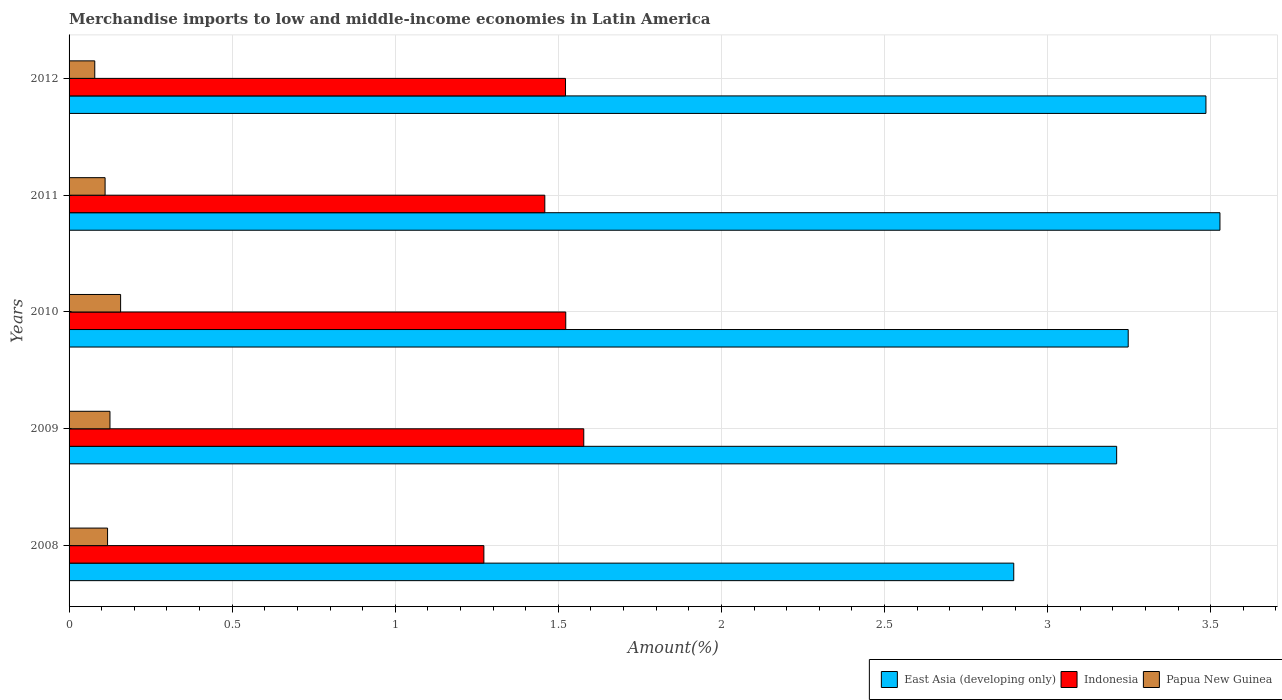How many different coloured bars are there?
Your answer should be compact. 3. How many groups of bars are there?
Give a very brief answer. 5. Are the number of bars on each tick of the Y-axis equal?
Make the answer very short. Yes. What is the label of the 4th group of bars from the top?
Ensure brevity in your answer.  2009. In how many cases, is the number of bars for a given year not equal to the number of legend labels?
Your response must be concise. 0. What is the percentage of amount earned from merchandise imports in East Asia (developing only) in 2008?
Offer a terse response. 2.9. Across all years, what is the maximum percentage of amount earned from merchandise imports in Papua New Guinea?
Offer a very short reply. 0.16. Across all years, what is the minimum percentage of amount earned from merchandise imports in Papua New Guinea?
Make the answer very short. 0.08. In which year was the percentage of amount earned from merchandise imports in Indonesia minimum?
Make the answer very short. 2008. What is the total percentage of amount earned from merchandise imports in Papua New Guinea in the graph?
Provide a succinct answer. 0.59. What is the difference between the percentage of amount earned from merchandise imports in Indonesia in 2009 and that in 2011?
Offer a terse response. 0.12. What is the difference between the percentage of amount earned from merchandise imports in Papua New Guinea in 2009 and the percentage of amount earned from merchandise imports in East Asia (developing only) in 2012?
Offer a very short reply. -3.36. What is the average percentage of amount earned from merchandise imports in Papua New Guinea per year?
Ensure brevity in your answer.  0.12. In the year 2009, what is the difference between the percentage of amount earned from merchandise imports in Indonesia and percentage of amount earned from merchandise imports in East Asia (developing only)?
Your response must be concise. -1.63. In how many years, is the percentage of amount earned from merchandise imports in Papua New Guinea greater than 2.7 %?
Ensure brevity in your answer.  0. What is the ratio of the percentage of amount earned from merchandise imports in East Asia (developing only) in 2010 to that in 2011?
Give a very brief answer. 0.92. What is the difference between the highest and the second highest percentage of amount earned from merchandise imports in Indonesia?
Your answer should be very brief. 0.06. What is the difference between the highest and the lowest percentage of amount earned from merchandise imports in Indonesia?
Make the answer very short. 0.31. In how many years, is the percentage of amount earned from merchandise imports in Papua New Guinea greater than the average percentage of amount earned from merchandise imports in Papua New Guinea taken over all years?
Offer a terse response. 2. What does the 3rd bar from the top in 2012 represents?
Ensure brevity in your answer.  East Asia (developing only). What does the 3rd bar from the bottom in 2012 represents?
Provide a short and direct response. Papua New Guinea. Is it the case that in every year, the sum of the percentage of amount earned from merchandise imports in East Asia (developing only) and percentage of amount earned from merchandise imports in Papua New Guinea is greater than the percentage of amount earned from merchandise imports in Indonesia?
Give a very brief answer. Yes. How many bars are there?
Provide a succinct answer. 15. Are all the bars in the graph horizontal?
Make the answer very short. Yes. How many years are there in the graph?
Provide a succinct answer. 5. What is the difference between two consecutive major ticks on the X-axis?
Make the answer very short. 0.5. Are the values on the major ticks of X-axis written in scientific E-notation?
Keep it short and to the point. No. Where does the legend appear in the graph?
Offer a very short reply. Bottom right. How many legend labels are there?
Ensure brevity in your answer.  3. What is the title of the graph?
Your answer should be very brief. Merchandise imports to low and middle-income economies in Latin America. Does "Portugal" appear as one of the legend labels in the graph?
Your answer should be compact. No. What is the label or title of the X-axis?
Provide a succinct answer. Amount(%). What is the Amount(%) in East Asia (developing only) in 2008?
Offer a very short reply. 2.9. What is the Amount(%) in Indonesia in 2008?
Ensure brevity in your answer.  1.27. What is the Amount(%) of Papua New Guinea in 2008?
Your answer should be compact. 0.12. What is the Amount(%) of East Asia (developing only) in 2009?
Your answer should be compact. 3.21. What is the Amount(%) of Indonesia in 2009?
Ensure brevity in your answer.  1.58. What is the Amount(%) in Papua New Guinea in 2009?
Provide a short and direct response. 0.13. What is the Amount(%) of East Asia (developing only) in 2010?
Make the answer very short. 3.25. What is the Amount(%) of Indonesia in 2010?
Offer a very short reply. 1.52. What is the Amount(%) of Papua New Guinea in 2010?
Make the answer very short. 0.16. What is the Amount(%) of East Asia (developing only) in 2011?
Make the answer very short. 3.53. What is the Amount(%) in Indonesia in 2011?
Provide a short and direct response. 1.46. What is the Amount(%) of Papua New Guinea in 2011?
Ensure brevity in your answer.  0.11. What is the Amount(%) in East Asia (developing only) in 2012?
Give a very brief answer. 3.49. What is the Amount(%) of Indonesia in 2012?
Provide a succinct answer. 1.52. What is the Amount(%) in Papua New Guinea in 2012?
Ensure brevity in your answer.  0.08. Across all years, what is the maximum Amount(%) in East Asia (developing only)?
Offer a terse response. 3.53. Across all years, what is the maximum Amount(%) of Indonesia?
Give a very brief answer. 1.58. Across all years, what is the maximum Amount(%) in Papua New Guinea?
Give a very brief answer. 0.16. Across all years, what is the minimum Amount(%) of East Asia (developing only)?
Keep it short and to the point. 2.9. Across all years, what is the minimum Amount(%) of Indonesia?
Provide a succinct answer. 1.27. Across all years, what is the minimum Amount(%) in Papua New Guinea?
Offer a very short reply. 0.08. What is the total Amount(%) in East Asia (developing only) in the graph?
Provide a succinct answer. 16.37. What is the total Amount(%) in Indonesia in the graph?
Your answer should be compact. 7.35. What is the total Amount(%) in Papua New Guinea in the graph?
Keep it short and to the point. 0.59. What is the difference between the Amount(%) in East Asia (developing only) in 2008 and that in 2009?
Your response must be concise. -0.32. What is the difference between the Amount(%) in Indonesia in 2008 and that in 2009?
Your answer should be very brief. -0.31. What is the difference between the Amount(%) in Papua New Guinea in 2008 and that in 2009?
Ensure brevity in your answer.  -0.01. What is the difference between the Amount(%) of East Asia (developing only) in 2008 and that in 2010?
Offer a terse response. -0.35. What is the difference between the Amount(%) of Indonesia in 2008 and that in 2010?
Give a very brief answer. -0.25. What is the difference between the Amount(%) in Papua New Guinea in 2008 and that in 2010?
Your answer should be compact. -0.04. What is the difference between the Amount(%) in East Asia (developing only) in 2008 and that in 2011?
Offer a terse response. -0.63. What is the difference between the Amount(%) in Indonesia in 2008 and that in 2011?
Your answer should be very brief. -0.19. What is the difference between the Amount(%) of Papua New Guinea in 2008 and that in 2011?
Keep it short and to the point. 0.01. What is the difference between the Amount(%) of East Asia (developing only) in 2008 and that in 2012?
Give a very brief answer. -0.59. What is the difference between the Amount(%) of Indonesia in 2008 and that in 2012?
Give a very brief answer. -0.25. What is the difference between the Amount(%) of Papua New Guinea in 2008 and that in 2012?
Provide a short and direct response. 0.04. What is the difference between the Amount(%) in East Asia (developing only) in 2009 and that in 2010?
Make the answer very short. -0.04. What is the difference between the Amount(%) of Indonesia in 2009 and that in 2010?
Keep it short and to the point. 0.06. What is the difference between the Amount(%) of Papua New Guinea in 2009 and that in 2010?
Your answer should be compact. -0.03. What is the difference between the Amount(%) of East Asia (developing only) in 2009 and that in 2011?
Keep it short and to the point. -0.32. What is the difference between the Amount(%) in Indonesia in 2009 and that in 2011?
Your response must be concise. 0.12. What is the difference between the Amount(%) of Papua New Guinea in 2009 and that in 2011?
Keep it short and to the point. 0.01. What is the difference between the Amount(%) in East Asia (developing only) in 2009 and that in 2012?
Your response must be concise. -0.27. What is the difference between the Amount(%) of Indonesia in 2009 and that in 2012?
Offer a terse response. 0.06. What is the difference between the Amount(%) of Papua New Guinea in 2009 and that in 2012?
Your answer should be very brief. 0.05. What is the difference between the Amount(%) in East Asia (developing only) in 2010 and that in 2011?
Offer a very short reply. -0.28. What is the difference between the Amount(%) of Indonesia in 2010 and that in 2011?
Your answer should be very brief. 0.06. What is the difference between the Amount(%) of Papua New Guinea in 2010 and that in 2011?
Your answer should be compact. 0.05. What is the difference between the Amount(%) of East Asia (developing only) in 2010 and that in 2012?
Offer a very short reply. -0.24. What is the difference between the Amount(%) in Indonesia in 2010 and that in 2012?
Give a very brief answer. 0. What is the difference between the Amount(%) in Papua New Guinea in 2010 and that in 2012?
Give a very brief answer. 0.08. What is the difference between the Amount(%) in East Asia (developing only) in 2011 and that in 2012?
Offer a very short reply. 0.04. What is the difference between the Amount(%) of Indonesia in 2011 and that in 2012?
Offer a very short reply. -0.06. What is the difference between the Amount(%) in Papua New Guinea in 2011 and that in 2012?
Offer a terse response. 0.03. What is the difference between the Amount(%) in East Asia (developing only) in 2008 and the Amount(%) in Indonesia in 2009?
Provide a succinct answer. 1.32. What is the difference between the Amount(%) in East Asia (developing only) in 2008 and the Amount(%) in Papua New Guinea in 2009?
Make the answer very short. 2.77. What is the difference between the Amount(%) of Indonesia in 2008 and the Amount(%) of Papua New Guinea in 2009?
Ensure brevity in your answer.  1.15. What is the difference between the Amount(%) of East Asia (developing only) in 2008 and the Amount(%) of Indonesia in 2010?
Provide a short and direct response. 1.37. What is the difference between the Amount(%) in East Asia (developing only) in 2008 and the Amount(%) in Papua New Guinea in 2010?
Give a very brief answer. 2.74. What is the difference between the Amount(%) in Indonesia in 2008 and the Amount(%) in Papua New Guinea in 2010?
Ensure brevity in your answer.  1.11. What is the difference between the Amount(%) of East Asia (developing only) in 2008 and the Amount(%) of Indonesia in 2011?
Your answer should be compact. 1.44. What is the difference between the Amount(%) in East Asia (developing only) in 2008 and the Amount(%) in Papua New Guinea in 2011?
Your answer should be very brief. 2.79. What is the difference between the Amount(%) of Indonesia in 2008 and the Amount(%) of Papua New Guinea in 2011?
Provide a short and direct response. 1.16. What is the difference between the Amount(%) of East Asia (developing only) in 2008 and the Amount(%) of Indonesia in 2012?
Keep it short and to the point. 1.37. What is the difference between the Amount(%) of East Asia (developing only) in 2008 and the Amount(%) of Papua New Guinea in 2012?
Give a very brief answer. 2.82. What is the difference between the Amount(%) of Indonesia in 2008 and the Amount(%) of Papua New Guinea in 2012?
Give a very brief answer. 1.19. What is the difference between the Amount(%) of East Asia (developing only) in 2009 and the Amount(%) of Indonesia in 2010?
Offer a very short reply. 1.69. What is the difference between the Amount(%) in East Asia (developing only) in 2009 and the Amount(%) in Papua New Guinea in 2010?
Offer a very short reply. 3.05. What is the difference between the Amount(%) in Indonesia in 2009 and the Amount(%) in Papua New Guinea in 2010?
Offer a very short reply. 1.42. What is the difference between the Amount(%) in East Asia (developing only) in 2009 and the Amount(%) in Indonesia in 2011?
Provide a succinct answer. 1.75. What is the difference between the Amount(%) of East Asia (developing only) in 2009 and the Amount(%) of Papua New Guinea in 2011?
Offer a very short reply. 3.1. What is the difference between the Amount(%) of Indonesia in 2009 and the Amount(%) of Papua New Guinea in 2011?
Your response must be concise. 1.47. What is the difference between the Amount(%) in East Asia (developing only) in 2009 and the Amount(%) in Indonesia in 2012?
Make the answer very short. 1.69. What is the difference between the Amount(%) in East Asia (developing only) in 2009 and the Amount(%) in Papua New Guinea in 2012?
Provide a short and direct response. 3.13. What is the difference between the Amount(%) in Indonesia in 2009 and the Amount(%) in Papua New Guinea in 2012?
Provide a succinct answer. 1.5. What is the difference between the Amount(%) of East Asia (developing only) in 2010 and the Amount(%) of Indonesia in 2011?
Make the answer very short. 1.79. What is the difference between the Amount(%) of East Asia (developing only) in 2010 and the Amount(%) of Papua New Guinea in 2011?
Your response must be concise. 3.14. What is the difference between the Amount(%) of Indonesia in 2010 and the Amount(%) of Papua New Guinea in 2011?
Offer a terse response. 1.41. What is the difference between the Amount(%) in East Asia (developing only) in 2010 and the Amount(%) in Indonesia in 2012?
Your response must be concise. 1.73. What is the difference between the Amount(%) in East Asia (developing only) in 2010 and the Amount(%) in Papua New Guinea in 2012?
Offer a terse response. 3.17. What is the difference between the Amount(%) in Indonesia in 2010 and the Amount(%) in Papua New Guinea in 2012?
Offer a terse response. 1.44. What is the difference between the Amount(%) in East Asia (developing only) in 2011 and the Amount(%) in Indonesia in 2012?
Your answer should be very brief. 2.01. What is the difference between the Amount(%) in East Asia (developing only) in 2011 and the Amount(%) in Papua New Guinea in 2012?
Offer a terse response. 3.45. What is the difference between the Amount(%) in Indonesia in 2011 and the Amount(%) in Papua New Guinea in 2012?
Your answer should be compact. 1.38. What is the average Amount(%) in East Asia (developing only) per year?
Give a very brief answer. 3.27. What is the average Amount(%) of Indonesia per year?
Provide a succinct answer. 1.47. What is the average Amount(%) in Papua New Guinea per year?
Give a very brief answer. 0.12. In the year 2008, what is the difference between the Amount(%) of East Asia (developing only) and Amount(%) of Indonesia?
Ensure brevity in your answer.  1.62. In the year 2008, what is the difference between the Amount(%) in East Asia (developing only) and Amount(%) in Papua New Guinea?
Your answer should be very brief. 2.78. In the year 2008, what is the difference between the Amount(%) in Indonesia and Amount(%) in Papua New Guinea?
Your answer should be compact. 1.15. In the year 2009, what is the difference between the Amount(%) of East Asia (developing only) and Amount(%) of Indonesia?
Offer a very short reply. 1.63. In the year 2009, what is the difference between the Amount(%) of East Asia (developing only) and Amount(%) of Papua New Guinea?
Offer a terse response. 3.09. In the year 2009, what is the difference between the Amount(%) of Indonesia and Amount(%) of Papua New Guinea?
Provide a succinct answer. 1.45. In the year 2010, what is the difference between the Amount(%) in East Asia (developing only) and Amount(%) in Indonesia?
Provide a short and direct response. 1.72. In the year 2010, what is the difference between the Amount(%) in East Asia (developing only) and Amount(%) in Papua New Guinea?
Your answer should be compact. 3.09. In the year 2010, what is the difference between the Amount(%) of Indonesia and Amount(%) of Papua New Guinea?
Your answer should be very brief. 1.36. In the year 2011, what is the difference between the Amount(%) in East Asia (developing only) and Amount(%) in Indonesia?
Your response must be concise. 2.07. In the year 2011, what is the difference between the Amount(%) of East Asia (developing only) and Amount(%) of Papua New Guinea?
Keep it short and to the point. 3.42. In the year 2011, what is the difference between the Amount(%) of Indonesia and Amount(%) of Papua New Guinea?
Your response must be concise. 1.35. In the year 2012, what is the difference between the Amount(%) in East Asia (developing only) and Amount(%) in Indonesia?
Give a very brief answer. 1.96. In the year 2012, what is the difference between the Amount(%) of East Asia (developing only) and Amount(%) of Papua New Guinea?
Give a very brief answer. 3.41. In the year 2012, what is the difference between the Amount(%) in Indonesia and Amount(%) in Papua New Guinea?
Keep it short and to the point. 1.44. What is the ratio of the Amount(%) of East Asia (developing only) in 2008 to that in 2009?
Make the answer very short. 0.9. What is the ratio of the Amount(%) in Indonesia in 2008 to that in 2009?
Make the answer very short. 0.81. What is the ratio of the Amount(%) in Papua New Guinea in 2008 to that in 2009?
Your response must be concise. 0.94. What is the ratio of the Amount(%) in East Asia (developing only) in 2008 to that in 2010?
Your answer should be compact. 0.89. What is the ratio of the Amount(%) in Indonesia in 2008 to that in 2010?
Make the answer very short. 0.84. What is the ratio of the Amount(%) in Papua New Guinea in 2008 to that in 2010?
Give a very brief answer. 0.75. What is the ratio of the Amount(%) in East Asia (developing only) in 2008 to that in 2011?
Keep it short and to the point. 0.82. What is the ratio of the Amount(%) of Indonesia in 2008 to that in 2011?
Your response must be concise. 0.87. What is the ratio of the Amount(%) in Papua New Guinea in 2008 to that in 2011?
Give a very brief answer. 1.07. What is the ratio of the Amount(%) in East Asia (developing only) in 2008 to that in 2012?
Offer a very short reply. 0.83. What is the ratio of the Amount(%) of Indonesia in 2008 to that in 2012?
Offer a very short reply. 0.84. What is the ratio of the Amount(%) of Papua New Guinea in 2008 to that in 2012?
Your response must be concise. 1.5. What is the ratio of the Amount(%) of Indonesia in 2009 to that in 2010?
Provide a succinct answer. 1.04. What is the ratio of the Amount(%) of Papua New Guinea in 2009 to that in 2010?
Make the answer very short. 0.79. What is the ratio of the Amount(%) of East Asia (developing only) in 2009 to that in 2011?
Provide a succinct answer. 0.91. What is the ratio of the Amount(%) of Indonesia in 2009 to that in 2011?
Ensure brevity in your answer.  1.08. What is the ratio of the Amount(%) in Papua New Guinea in 2009 to that in 2011?
Give a very brief answer. 1.14. What is the ratio of the Amount(%) in East Asia (developing only) in 2009 to that in 2012?
Offer a terse response. 0.92. What is the ratio of the Amount(%) of Indonesia in 2009 to that in 2012?
Your response must be concise. 1.04. What is the ratio of the Amount(%) of Papua New Guinea in 2009 to that in 2012?
Offer a terse response. 1.59. What is the ratio of the Amount(%) in East Asia (developing only) in 2010 to that in 2011?
Your response must be concise. 0.92. What is the ratio of the Amount(%) in Indonesia in 2010 to that in 2011?
Give a very brief answer. 1.04. What is the ratio of the Amount(%) of Papua New Guinea in 2010 to that in 2011?
Give a very brief answer. 1.43. What is the ratio of the Amount(%) in East Asia (developing only) in 2010 to that in 2012?
Make the answer very short. 0.93. What is the ratio of the Amount(%) of Papua New Guinea in 2010 to that in 2012?
Your response must be concise. 2.01. What is the ratio of the Amount(%) of East Asia (developing only) in 2011 to that in 2012?
Your answer should be very brief. 1.01. What is the ratio of the Amount(%) in Indonesia in 2011 to that in 2012?
Ensure brevity in your answer.  0.96. What is the ratio of the Amount(%) of Papua New Guinea in 2011 to that in 2012?
Keep it short and to the point. 1.4. What is the difference between the highest and the second highest Amount(%) in East Asia (developing only)?
Your answer should be compact. 0.04. What is the difference between the highest and the second highest Amount(%) in Indonesia?
Your response must be concise. 0.06. What is the difference between the highest and the second highest Amount(%) in Papua New Guinea?
Offer a very short reply. 0.03. What is the difference between the highest and the lowest Amount(%) in East Asia (developing only)?
Ensure brevity in your answer.  0.63. What is the difference between the highest and the lowest Amount(%) of Indonesia?
Your answer should be compact. 0.31. What is the difference between the highest and the lowest Amount(%) in Papua New Guinea?
Offer a very short reply. 0.08. 